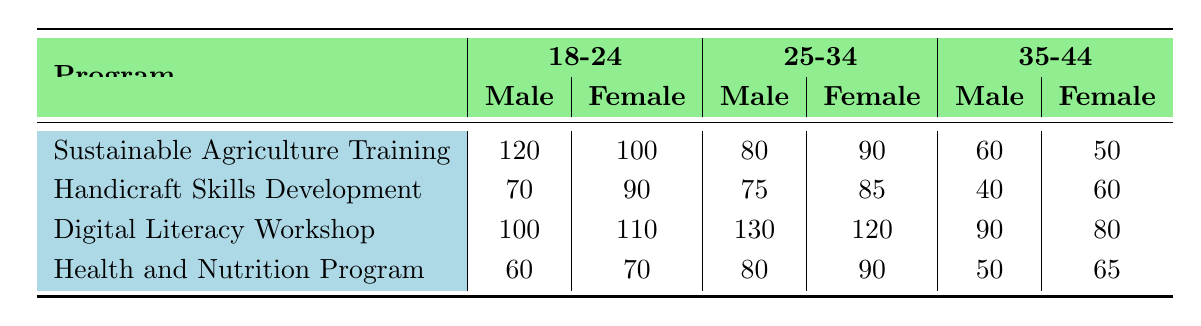What is the total number of male participants in the Digital Literacy Workshop? Referring to the "Digital Literacy Workshop" row, the number of male participants is 100 (18-24 age group) + 130 (25-34 age group) + 90 (35-44 age group) = 320.
Answer: 320 What is the age group with the highest number of female participants in the Sustainable Agriculture Training program? Looking at the "Sustainable Agriculture Training" row, the female participants are 100 (18-24) + 90 (25-34) + 50 (35-44). The highest number is 100 in the 18-24 age group.
Answer: 18-24 How many more male participants are there in the Handicraft Skills Development program compared to the Health and Nutrition Program? For Handicraft Skills, male participants are 70 (18-24) + 75 (25-34) + 40 (35-44) = 185. For Health and Nutrition, male participants are 60 (18-24) + 80 (25-34) + 50 (35-44) = 190. Thus, 185 - 190 = -5, meaning there are 5 more participants in Health and Nutrition.
Answer: 5 more in Health and Nutrition What is the average number of male participants across all programs in the age group 25-34? The male participant numbers for 25-34 across programs are: 80 (Sustainable Agriculture) + 75 (Handicraft Skills) + 130 (Digital Literacy Workshop) + 80 (Health and Nutrition) = 365. There are 4 programs, so the average is 365 / 4 = 91.25.
Answer: 91.25 Which age group has the least female participation in the Handicraft Skills Development program? In the "Handicraft Skills Development" row, female participation numbers are 90 (18-24) + 85 (25-34) + 60 (35-44). The least number is in the 35-44 age group with 60 participants.
Answer: 35-44 Is there a higher total number of participants (male and female combined) in the Digital Literacy Workshop compared to the Health and Nutrition Program? The total for Digital Literacy Workshop is (100 + 110 + 130 + 120 + 90 + 80) = 730. The total for Health and Nutrition Program is (60 + 70 + 80 + 90 + 50 + 65) = 415. Since 730 > 415, The statement is true.
Answer: Yes What is the difference in the number of male participants between the oldest age group (35-44) in the Sustainable Agriculture Training and Digital Literacy Workshop? Male participants are 60 in Sustainable Agriculture and 90 in Digital Literacy for the 35-44 age group. The difference is 90 - 60 = 30.
Answer: 30 What percentage of male participants in the Health and Nutrition Program are aged 18-24? In Health and Nutrition Program, male participants are 60 (18-24) + 80 (25-34) + 50 (35-44) = 190 total. The percentage for 18-24 is (60 / 190) * 100 = 31.58%.
Answer: 31.58% 